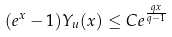Convert formula to latex. <formula><loc_0><loc_0><loc_500><loc_500>( e ^ { x } - 1 ) Y _ { u } ( x ) \leq C e ^ { \frac { q x } { q - 1 } }</formula> 